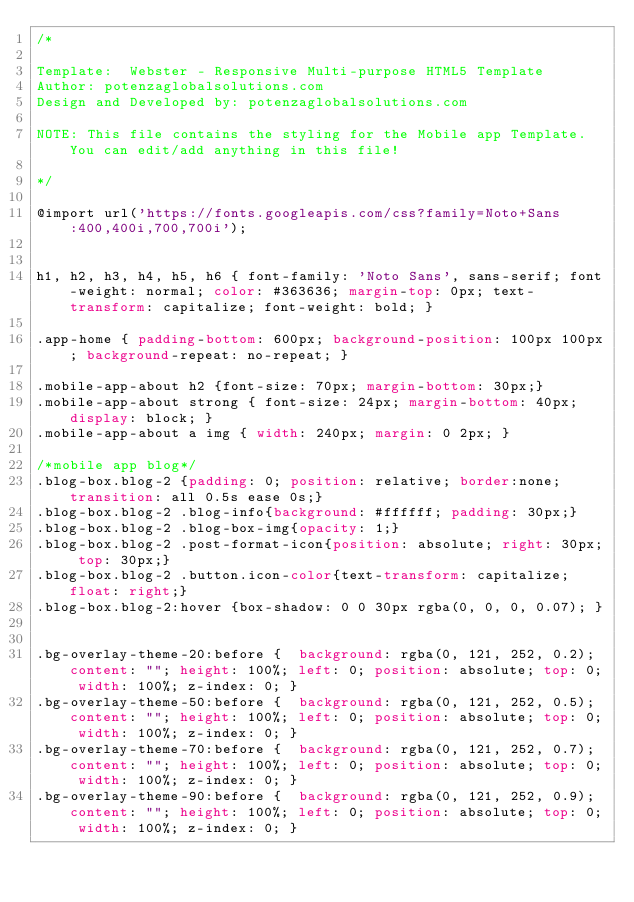Convert code to text. <code><loc_0><loc_0><loc_500><loc_500><_CSS_>/*

Template:  Webster - Responsive Multi-purpose HTML5 Template
Author: potenzaglobalsolutions.com
Design and Developed by: potenzaglobalsolutions.com

NOTE: This file contains the styling for the Mobile app Template. You can edit/add anything in this file!

*/
 
@import url('https://fonts.googleapis.com/css?family=Noto+Sans:400,400i,700,700i');

 
h1, h2, h3, h4, h5, h6 { font-family: 'Noto Sans', sans-serif; font-weight: normal; color: #363636; margin-top: 0px; text-transform: capitalize; font-weight: bold; }

.app-home { padding-bottom: 600px; background-position: 100px 100px; background-repeat: no-repeat; }
 
.mobile-app-about h2 {font-size: 70px; margin-bottom: 30px;}
.mobile-app-about strong { font-size: 24px; margin-bottom: 40px; display: block; }
.mobile-app-about a img { width: 240px; margin: 0 2px; }

/*mobile app blog*/
.blog-box.blog-2 {padding: 0; position: relative; border:none; transition: all 0.5s ease 0s;}
.blog-box.blog-2 .blog-info{background: #ffffff; padding: 30px;}
.blog-box.blog-2 .blog-box-img{opacity: 1;}
.blog-box.blog-2 .post-format-icon{position: absolute; right: 30px; top: 30px;}
.blog-box.blog-2 .button.icon-color{text-transform: capitalize; float: right;}
.blog-box.blog-2:hover {box-shadow: 0 0 30px rgba(0, 0, 0, 0.07); }


.bg-overlay-theme-20:before {  background: rgba(0, 121, 252, 0.2); content: ""; height: 100%; left: 0; position: absolute; top: 0; width: 100%; z-index: 0; }
.bg-overlay-theme-50:before {  background: rgba(0, 121, 252, 0.5); content: ""; height: 100%; left: 0; position: absolute; top: 0; width: 100%; z-index: 0; }
.bg-overlay-theme-70:before {  background: rgba(0, 121, 252, 0.7); content: ""; height: 100%; left: 0; position: absolute; top: 0; width: 100%; z-index: 0; }
.bg-overlay-theme-90:before {  background: rgba(0, 121, 252, 0.9); content: ""; height: 100%; left: 0; position: absolute; top: 0; width: 100%; z-index: 0; }</code> 